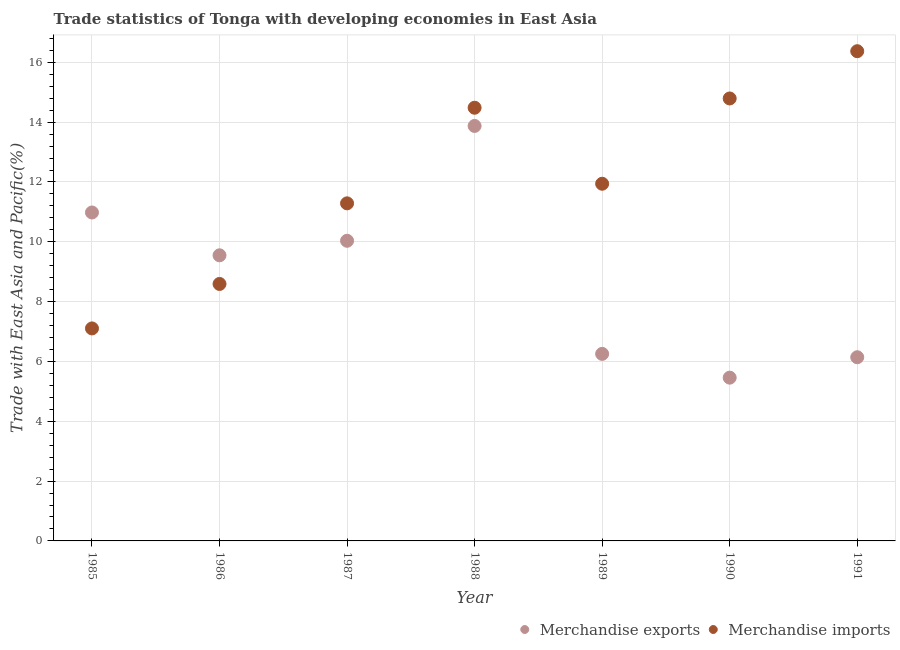Is the number of dotlines equal to the number of legend labels?
Offer a very short reply. Yes. What is the merchandise imports in 1991?
Make the answer very short. 16.37. Across all years, what is the maximum merchandise imports?
Ensure brevity in your answer.  16.37. Across all years, what is the minimum merchandise imports?
Offer a terse response. 7.1. In which year was the merchandise exports maximum?
Give a very brief answer. 1988. What is the total merchandise exports in the graph?
Provide a short and direct response. 62.29. What is the difference between the merchandise imports in 1988 and that in 1990?
Your answer should be very brief. -0.31. What is the difference between the merchandise imports in 1985 and the merchandise exports in 1987?
Your answer should be very brief. -2.93. What is the average merchandise imports per year?
Provide a short and direct response. 12.08. In the year 1987, what is the difference between the merchandise imports and merchandise exports?
Provide a succinct answer. 1.25. In how many years, is the merchandise imports greater than 9.2 %?
Provide a succinct answer. 5. What is the ratio of the merchandise imports in 1986 to that in 1991?
Keep it short and to the point. 0.52. What is the difference between the highest and the second highest merchandise exports?
Ensure brevity in your answer.  2.89. What is the difference between the highest and the lowest merchandise exports?
Keep it short and to the point. 8.42. Is the sum of the merchandise imports in 1987 and 1988 greater than the maximum merchandise exports across all years?
Provide a short and direct response. Yes. Does the merchandise imports monotonically increase over the years?
Provide a short and direct response. No. Is the merchandise imports strictly greater than the merchandise exports over the years?
Make the answer very short. No. How many dotlines are there?
Offer a terse response. 2. What is the difference between two consecutive major ticks on the Y-axis?
Offer a very short reply. 2. How many legend labels are there?
Make the answer very short. 2. What is the title of the graph?
Offer a very short reply. Trade statistics of Tonga with developing economies in East Asia. Does "Domestic Liabilities" appear as one of the legend labels in the graph?
Offer a very short reply. No. What is the label or title of the Y-axis?
Provide a short and direct response. Trade with East Asia and Pacific(%). What is the Trade with East Asia and Pacific(%) in Merchandise exports in 1985?
Give a very brief answer. 10.98. What is the Trade with East Asia and Pacific(%) of Merchandise imports in 1985?
Make the answer very short. 7.1. What is the Trade with East Asia and Pacific(%) in Merchandise exports in 1986?
Your answer should be compact. 9.55. What is the Trade with East Asia and Pacific(%) of Merchandise imports in 1986?
Give a very brief answer. 8.59. What is the Trade with East Asia and Pacific(%) in Merchandise exports in 1987?
Offer a very short reply. 10.03. What is the Trade with East Asia and Pacific(%) of Merchandise imports in 1987?
Your answer should be very brief. 11.29. What is the Trade with East Asia and Pacific(%) in Merchandise exports in 1988?
Give a very brief answer. 13.87. What is the Trade with East Asia and Pacific(%) in Merchandise imports in 1988?
Make the answer very short. 14.48. What is the Trade with East Asia and Pacific(%) of Merchandise exports in 1989?
Ensure brevity in your answer.  6.25. What is the Trade with East Asia and Pacific(%) of Merchandise imports in 1989?
Your answer should be very brief. 11.94. What is the Trade with East Asia and Pacific(%) of Merchandise exports in 1990?
Your answer should be very brief. 5.46. What is the Trade with East Asia and Pacific(%) in Merchandise imports in 1990?
Your answer should be compact. 14.79. What is the Trade with East Asia and Pacific(%) of Merchandise exports in 1991?
Make the answer very short. 6.14. What is the Trade with East Asia and Pacific(%) of Merchandise imports in 1991?
Provide a succinct answer. 16.37. Across all years, what is the maximum Trade with East Asia and Pacific(%) of Merchandise exports?
Keep it short and to the point. 13.87. Across all years, what is the maximum Trade with East Asia and Pacific(%) in Merchandise imports?
Make the answer very short. 16.37. Across all years, what is the minimum Trade with East Asia and Pacific(%) of Merchandise exports?
Offer a very short reply. 5.46. Across all years, what is the minimum Trade with East Asia and Pacific(%) of Merchandise imports?
Provide a succinct answer. 7.1. What is the total Trade with East Asia and Pacific(%) in Merchandise exports in the graph?
Provide a succinct answer. 62.29. What is the total Trade with East Asia and Pacific(%) in Merchandise imports in the graph?
Offer a very short reply. 84.57. What is the difference between the Trade with East Asia and Pacific(%) of Merchandise exports in 1985 and that in 1986?
Make the answer very short. 1.43. What is the difference between the Trade with East Asia and Pacific(%) of Merchandise imports in 1985 and that in 1986?
Provide a succinct answer. -1.49. What is the difference between the Trade with East Asia and Pacific(%) of Merchandise exports in 1985 and that in 1987?
Offer a terse response. 0.95. What is the difference between the Trade with East Asia and Pacific(%) of Merchandise imports in 1985 and that in 1987?
Keep it short and to the point. -4.18. What is the difference between the Trade with East Asia and Pacific(%) in Merchandise exports in 1985 and that in 1988?
Make the answer very short. -2.89. What is the difference between the Trade with East Asia and Pacific(%) of Merchandise imports in 1985 and that in 1988?
Keep it short and to the point. -7.38. What is the difference between the Trade with East Asia and Pacific(%) in Merchandise exports in 1985 and that in 1989?
Make the answer very short. 4.73. What is the difference between the Trade with East Asia and Pacific(%) in Merchandise imports in 1985 and that in 1989?
Your answer should be very brief. -4.84. What is the difference between the Trade with East Asia and Pacific(%) of Merchandise exports in 1985 and that in 1990?
Provide a short and direct response. 5.52. What is the difference between the Trade with East Asia and Pacific(%) in Merchandise imports in 1985 and that in 1990?
Provide a succinct answer. -7.69. What is the difference between the Trade with East Asia and Pacific(%) in Merchandise exports in 1985 and that in 1991?
Your response must be concise. 4.84. What is the difference between the Trade with East Asia and Pacific(%) in Merchandise imports in 1985 and that in 1991?
Provide a succinct answer. -9.27. What is the difference between the Trade with East Asia and Pacific(%) in Merchandise exports in 1986 and that in 1987?
Provide a succinct answer. -0.49. What is the difference between the Trade with East Asia and Pacific(%) of Merchandise imports in 1986 and that in 1987?
Your response must be concise. -2.69. What is the difference between the Trade with East Asia and Pacific(%) of Merchandise exports in 1986 and that in 1988?
Your answer should be compact. -4.32. What is the difference between the Trade with East Asia and Pacific(%) in Merchandise imports in 1986 and that in 1988?
Your response must be concise. -5.89. What is the difference between the Trade with East Asia and Pacific(%) in Merchandise exports in 1986 and that in 1989?
Ensure brevity in your answer.  3.3. What is the difference between the Trade with East Asia and Pacific(%) in Merchandise imports in 1986 and that in 1989?
Give a very brief answer. -3.35. What is the difference between the Trade with East Asia and Pacific(%) in Merchandise exports in 1986 and that in 1990?
Give a very brief answer. 4.09. What is the difference between the Trade with East Asia and Pacific(%) of Merchandise imports in 1986 and that in 1990?
Keep it short and to the point. -6.2. What is the difference between the Trade with East Asia and Pacific(%) in Merchandise exports in 1986 and that in 1991?
Provide a succinct answer. 3.41. What is the difference between the Trade with East Asia and Pacific(%) in Merchandise imports in 1986 and that in 1991?
Keep it short and to the point. -7.78. What is the difference between the Trade with East Asia and Pacific(%) of Merchandise exports in 1987 and that in 1988?
Offer a terse response. -3.84. What is the difference between the Trade with East Asia and Pacific(%) in Merchandise imports in 1987 and that in 1988?
Provide a succinct answer. -3.2. What is the difference between the Trade with East Asia and Pacific(%) in Merchandise exports in 1987 and that in 1989?
Your answer should be compact. 3.78. What is the difference between the Trade with East Asia and Pacific(%) in Merchandise imports in 1987 and that in 1989?
Provide a short and direct response. -0.66. What is the difference between the Trade with East Asia and Pacific(%) of Merchandise exports in 1987 and that in 1990?
Provide a short and direct response. 4.58. What is the difference between the Trade with East Asia and Pacific(%) of Merchandise imports in 1987 and that in 1990?
Offer a very short reply. -3.51. What is the difference between the Trade with East Asia and Pacific(%) of Merchandise exports in 1987 and that in 1991?
Your answer should be very brief. 3.89. What is the difference between the Trade with East Asia and Pacific(%) of Merchandise imports in 1987 and that in 1991?
Make the answer very short. -5.09. What is the difference between the Trade with East Asia and Pacific(%) of Merchandise exports in 1988 and that in 1989?
Your answer should be compact. 7.62. What is the difference between the Trade with East Asia and Pacific(%) in Merchandise imports in 1988 and that in 1989?
Keep it short and to the point. 2.54. What is the difference between the Trade with East Asia and Pacific(%) in Merchandise exports in 1988 and that in 1990?
Your answer should be very brief. 8.42. What is the difference between the Trade with East Asia and Pacific(%) in Merchandise imports in 1988 and that in 1990?
Provide a succinct answer. -0.31. What is the difference between the Trade with East Asia and Pacific(%) in Merchandise exports in 1988 and that in 1991?
Your response must be concise. 7.73. What is the difference between the Trade with East Asia and Pacific(%) in Merchandise imports in 1988 and that in 1991?
Provide a succinct answer. -1.89. What is the difference between the Trade with East Asia and Pacific(%) in Merchandise exports in 1989 and that in 1990?
Offer a terse response. 0.8. What is the difference between the Trade with East Asia and Pacific(%) in Merchandise imports in 1989 and that in 1990?
Your response must be concise. -2.85. What is the difference between the Trade with East Asia and Pacific(%) in Merchandise exports in 1989 and that in 1991?
Make the answer very short. 0.11. What is the difference between the Trade with East Asia and Pacific(%) in Merchandise imports in 1989 and that in 1991?
Offer a terse response. -4.43. What is the difference between the Trade with East Asia and Pacific(%) of Merchandise exports in 1990 and that in 1991?
Ensure brevity in your answer.  -0.68. What is the difference between the Trade with East Asia and Pacific(%) of Merchandise imports in 1990 and that in 1991?
Keep it short and to the point. -1.58. What is the difference between the Trade with East Asia and Pacific(%) in Merchandise exports in 1985 and the Trade with East Asia and Pacific(%) in Merchandise imports in 1986?
Keep it short and to the point. 2.39. What is the difference between the Trade with East Asia and Pacific(%) in Merchandise exports in 1985 and the Trade with East Asia and Pacific(%) in Merchandise imports in 1987?
Ensure brevity in your answer.  -0.31. What is the difference between the Trade with East Asia and Pacific(%) in Merchandise exports in 1985 and the Trade with East Asia and Pacific(%) in Merchandise imports in 1988?
Give a very brief answer. -3.5. What is the difference between the Trade with East Asia and Pacific(%) of Merchandise exports in 1985 and the Trade with East Asia and Pacific(%) of Merchandise imports in 1989?
Ensure brevity in your answer.  -0.96. What is the difference between the Trade with East Asia and Pacific(%) in Merchandise exports in 1985 and the Trade with East Asia and Pacific(%) in Merchandise imports in 1990?
Ensure brevity in your answer.  -3.81. What is the difference between the Trade with East Asia and Pacific(%) in Merchandise exports in 1985 and the Trade with East Asia and Pacific(%) in Merchandise imports in 1991?
Give a very brief answer. -5.39. What is the difference between the Trade with East Asia and Pacific(%) of Merchandise exports in 1986 and the Trade with East Asia and Pacific(%) of Merchandise imports in 1987?
Your answer should be compact. -1.74. What is the difference between the Trade with East Asia and Pacific(%) of Merchandise exports in 1986 and the Trade with East Asia and Pacific(%) of Merchandise imports in 1988?
Make the answer very short. -4.93. What is the difference between the Trade with East Asia and Pacific(%) in Merchandise exports in 1986 and the Trade with East Asia and Pacific(%) in Merchandise imports in 1989?
Offer a very short reply. -2.39. What is the difference between the Trade with East Asia and Pacific(%) of Merchandise exports in 1986 and the Trade with East Asia and Pacific(%) of Merchandise imports in 1990?
Provide a succinct answer. -5.24. What is the difference between the Trade with East Asia and Pacific(%) of Merchandise exports in 1986 and the Trade with East Asia and Pacific(%) of Merchandise imports in 1991?
Your answer should be compact. -6.82. What is the difference between the Trade with East Asia and Pacific(%) of Merchandise exports in 1987 and the Trade with East Asia and Pacific(%) of Merchandise imports in 1988?
Offer a very short reply. -4.45. What is the difference between the Trade with East Asia and Pacific(%) of Merchandise exports in 1987 and the Trade with East Asia and Pacific(%) of Merchandise imports in 1989?
Ensure brevity in your answer.  -1.91. What is the difference between the Trade with East Asia and Pacific(%) in Merchandise exports in 1987 and the Trade with East Asia and Pacific(%) in Merchandise imports in 1990?
Offer a very short reply. -4.76. What is the difference between the Trade with East Asia and Pacific(%) in Merchandise exports in 1987 and the Trade with East Asia and Pacific(%) in Merchandise imports in 1991?
Offer a terse response. -6.34. What is the difference between the Trade with East Asia and Pacific(%) in Merchandise exports in 1988 and the Trade with East Asia and Pacific(%) in Merchandise imports in 1989?
Your response must be concise. 1.93. What is the difference between the Trade with East Asia and Pacific(%) in Merchandise exports in 1988 and the Trade with East Asia and Pacific(%) in Merchandise imports in 1990?
Offer a very short reply. -0.92. What is the difference between the Trade with East Asia and Pacific(%) in Merchandise exports in 1988 and the Trade with East Asia and Pacific(%) in Merchandise imports in 1991?
Give a very brief answer. -2.5. What is the difference between the Trade with East Asia and Pacific(%) in Merchandise exports in 1989 and the Trade with East Asia and Pacific(%) in Merchandise imports in 1990?
Your response must be concise. -8.54. What is the difference between the Trade with East Asia and Pacific(%) of Merchandise exports in 1989 and the Trade with East Asia and Pacific(%) of Merchandise imports in 1991?
Ensure brevity in your answer.  -10.12. What is the difference between the Trade with East Asia and Pacific(%) of Merchandise exports in 1990 and the Trade with East Asia and Pacific(%) of Merchandise imports in 1991?
Provide a succinct answer. -10.91. What is the average Trade with East Asia and Pacific(%) of Merchandise exports per year?
Provide a short and direct response. 8.9. What is the average Trade with East Asia and Pacific(%) of Merchandise imports per year?
Your response must be concise. 12.08. In the year 1985, what is the difference between the Trade with East Asia and Pacific(%) in Merchandise exports and Trade with East Asia and Pacific(%) in Merchandise imports?
Provide a short and direct response. 3.88. In the year 1986, what is the difference between the Trade with East Asia and Pacific(%) of Merchandise exports and Trade with East Asia and Pacific(%) of Merchandise imports?
Your answer should be very brief. 0.96. In the year 1987, what is the difference between the Trade with East Asia and Pacific(%) of Merchandise exports and Trade with East Asia and Pacific(%) of Merchandise imports?
Your answer should be compact. -1.25. In the year 1988, what is the difference between the Trade with East Asia and Pacific(%) of Merchandise exports and Trade with East Asia and Pacific(%) of Merchandise imports?
Give a very brief answer. -0.61. In the year 1989, what is the difference between the Trade with East Asia and Pacific(%) in Merchandise exports and Trade with East Asia and Pacific(%) in Merchandise imports?
Your response must be concise. -5.69. In the year 1990, what is the difference between the Trade with East Asia and Pacific(%) in Merchandise exports and Trade with East Asia and Pacific(%) in Merchandise imports?
Keep it short and to the point. -9.33. In the year 1991, what is the difference between the Trade with East Asia and Pacific(%) in Merchandise exports and Trade with East Asia and Pacific(%) in Merchandise imports?
Your answer should be compact. -10.23. What is the ratio of the Trade with East Asia and Pacific(%) of Merchandise exports in 1985 to that in 1986?
Offer a terse response. 1.15. What is the ratio of the Trade with East Asia and Pacific(%) of Merchandise imports in 1985 to that in 1986?
Make the answer very short. 0.83. What is the ratio of the Trade with East Asia and Pacific(%) in Merchandise exports in 1985 to that in 1987?
Your answer should be compact. 1.09. What is the ratio of the Trade with East Asia and Pacific(%) of Merchandise imports in 1985 to that in 1987?
Give a very brief answer. 0.63. What is the ratio of the Trade with East Asia and Pacific(%) in Merchandise exports in 1985 to that in 1988?
Your answer should be compact. 0.79. What is the ratio of the Trade with East Asia and Pacific(%) in Merchandise imports in 1985 to that in 1988?
Provide a succinct answer. 0.49. What is the ratio of the Trade with East Asia and Pacific(%) of Merchandise exports in 1985 to that in 1989?
Your response must be concise. 1.76. What is the ratio of the Trade with East Asia and Pacific(%) in Merchandise imports in 1985 to that in 1989?
Ensure brevity in your answer.  0.59. What is the ratio of the Trade with East Asia and Pacific(%) in Merchandise exports in 1985 to that in 1990?
Provide a succinct answer. 2.01. What is the ratio of the Trade with East Asia and Pacific(%) of Merchandise imports in 1985 to that in 1990?
Provide a short and direct response. 0.48. What is the ratio of the Trade with East Asia and Pacific(%) of Merchandise exports in 1985 to that in 1991?
Provide a succinct answer. 1.79. What is the ratio of the Trade with East Asia and Pacific(%) in Merchandise imports in 1985 to that in 1991?
Provide a succinct answer. 0.43. What is the ratio of the Trade with East Asia and Pacific(%) in Merchandise exports in 1986 to that in 1987?
Ensure brevity in your answer.  0.95. What is the ratio of the Trade with East Asia and Pacific(%) in Merchandise imports in 1986 to that in 1987?
Offer a very short reply. 0.76. What is the ratio of the Trade with East Asia and Pacific(%) in Merchandise exports in 1986 to that in 1988?
Your answer should be very brief. 0.69. What is the ratio of the Trade with East Asia and Pacific(%) in Merchandise imports in 1986 to that in 1988?
Your response must be concise. 0.59. What is the ratio of the Trade with East Asia and Pacific(%) in Merchandise exports in 1986 to that in 1989?
Your response must be concise. 1.53. What is the ratio of the Trade with East Asia and Pacific(%) in Merchandise imports in 1986 to that in 1989?
Keep it short and to the point. 0.72. What is the ratio of the Trade with East Asia and Pacific(%) of Merchandise exports in 1986 to that in 1990?
Make the answer very short. 1.75. What is the ratio of the Trade with East Asia and Pacific(%) in Merchandise imports in 1986 to that in 1990?
Ensure brevity in your answer.  0.58. What is the ratio of the Trade with East Asia and Pacific(%) in Merchandise exports in 1986 to that in 1991?
Offer a very short reply. 1.55. What is the ratio of the Trade with East Asia and Pacific(%) of Merchandise imports in 1986 to that in 1991?
Give a very brief answer. 0.52. What is the ratio of the Trade with East Asia and Pacific(%) of Merchandise exports in 1987 to that in 1988?
Provide a succinct answer. 0.72. What is the ratio of the Trade with East Asia and Pacific(%) of Merchandise imports in 1987 to that in 1988?
Provide a short and direct response. 0.78. What is the ratio of the Trade with East Asia and Pacific(%) in Merchandise exports in 1987 to that in 1989?
Your answer should be compact. 1.6. What is the ratio of the Trade with East Asia and Pacific(%) of Merchandise imports in 1987 to that in 1989?
Make the answer very short. 0.95. What is the ratio of the Trade with East Asia and Pacific(%) in Merchandise exports in 1987 to that in 1990?
Your answer should be very brief. 1.84. What is the ratio of the Trade with East Asia and Pacific(%) of Merchandise imports in 1987 to that in 1990?
Ensure brevity in your answer.  0.76. What is the ratio of the Trade with East Asia and Pacific(%) of Merchandise exports in 1987 to that in 1991?
Your answer should be very brief. 1.63. What is the ratio of the Trade with East Asia and Pacific(%) of Merchandise imports in 1987 to that in 1991?
Ensure brevity in your answer.  0.69. What is the ratio of the Trade with East Asia and Pacific(%) in Merchandise exports in 1988 to that in 1989?
Make the answer very short. 2.22. What is the ratio of the Trade with East Asia and Pacific(%) in Merchandise imports in 1988 to that in 1989?
Ensure brevity in your answer.  1.21. What is the ratio of the Trade with East Asia and Pacific(%) in Merchandise exports in 1988 to that in 1990?
Provide a short and direct response. 2.54. What is the ratio of the Trade with East Asia and Pacific(%) in Merchandise imports in 1988 to that in 1990?
Provide a short and direct response. 0.98. What is the ratio of the Trade with East Asia and Pacific(%) in Merchandise exports in 1988 to that in 1991?
Provide a short and direct response. 2.26. What is the ratio of the Trade with East Asia and Pacific(%) of Merchandise imports in 1988 to that in 1991?
Offer a very short reply. 0.88. What is the ratio of the Trade with East Asia and Pacific(%) in Merchandise exports in 1989 to that in 1990?
Provide a succinct answer. 1.15. What is the ratio of the Trade with East Asia and Pacific(%) of Merchandise imports in 1989 to that in 1990?
Your answer should be very brief. 0.81. What is the ratio of the Trade with East Asia and Pacific(%) of Merchandise exports in 1989 to that in 1991?
Provide a succinct answer. 1.02. What is the ratio of the Trade with East Asia and Pacific(%) in Merchandise imports in 1989 to that in 1991?
Provide a short and direct response. 0.73. What is the ratio of the Trade with East Asia and Pacific(%) of Merchandise exports in 1990 to that in 1991?
Ensure brevity in your answer.  0.89. What is the ratio of the Trade with East Asia and Pacific(%) of Merchandise imports in 1990 to that in 1991?
Ensure brevity in your answer.  0.9. What is the difference between the highest and the second highest Trade with East Asia and Pacific(%) in Merchandise exports?
Provide a succinct answer. 2.89. What is the difference between the highest and the second highest Trade with East Asia and Pacific(%) in Merchandise imports?
Give a very brief answer. 1.58. What is the difference between the highest and the lowest Trade with East Asia and Pacific(%) of Merchandise exports?
Keep it short and to the point. 8.42. What is the difference between the highest and the lowest Trade with East Asia and Pacific(%) of Merchandise imports?
Ensure brevity in your answer.  9.27. 